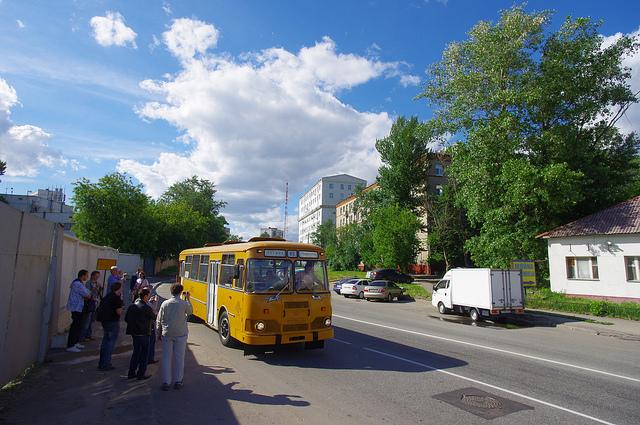What season was the photo taken?
Short answer required. Spring. Where is the bus headed?
Give a very brief answer. Downtown. How many vehicles are the photo?
Quick response, please. 5. Are there any people waiting for the bus?
Write a very short answer. Yes. 